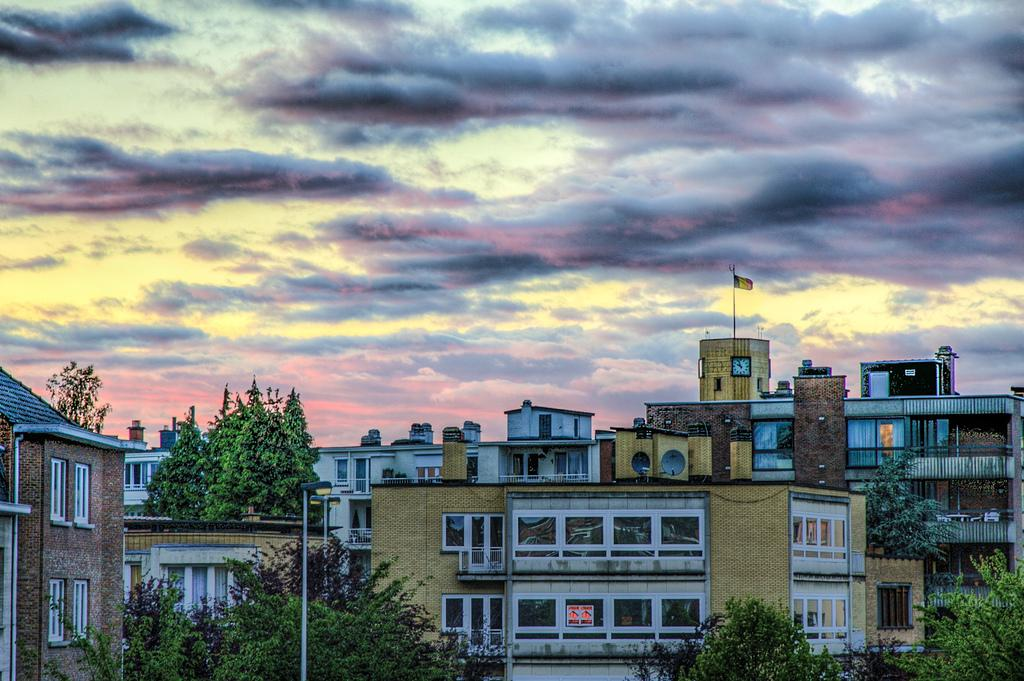What type of structures can be seen in the image? There are buildings in the image. What architectural features are present on the buildings? There are windows visible on the buildings. What type of vegetation is present in the image? There are trees in the image. What is used to display flags in the image? There are flagpoles in the image. What can be seen in the background of the image? The sky is visible in the image. How many apples are hanging from the trees in the image? There are no apples present in the image; it features trees without any visible fruit. Can you tell me how many rats are sleeping on the windowsills in the image? There are no rats present in the image, and therefore no such activity can be observed. 